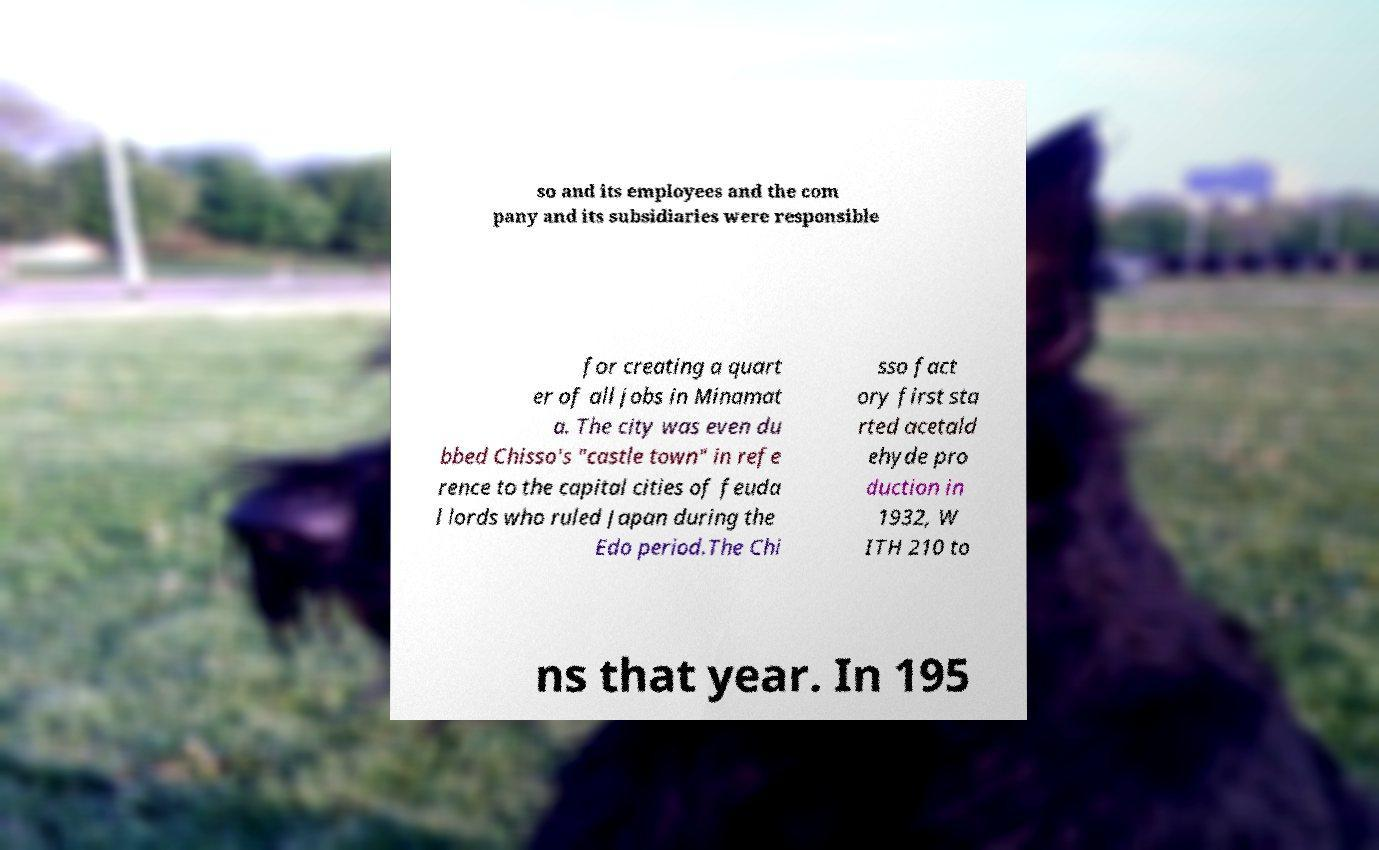Can you read and provide the text displayed in the image?This photo seems to have some interesting text. Can you extract and type it out for me? so and its employees and the com pany and its subsidiaries were responsible for creating a quart er of all jobs in Minamat a. The city was even du bbed Chisso's "castle town" in refe rence to the capital cities of feuda l lords who ruled Japan during the Edo period.The Chi sso fact ory first sta rted acetald ehyde pro duction in 1932, W ITH 210 to ns that year. In 195 